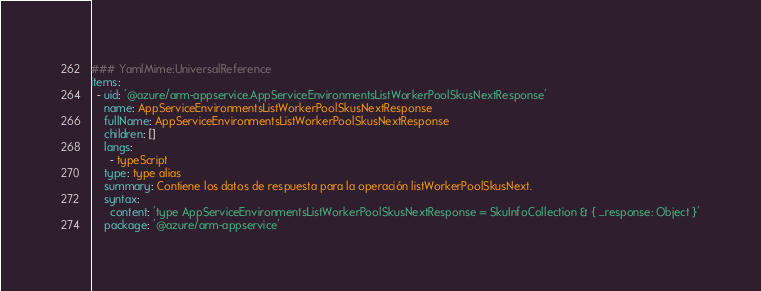<code> <loc_0><loc_0><loc_500><loc_500><_YAML_>### YamlMime:UniversalReference
items:
  - uid: '@azure/arm-appservice.AppServiceEnvironmentsListWorkerPoolSkusNextResponse'
    name: AppServiceEnvironmentsListWorkerPoolSkusNextResponse
    fullName: AppServiceEnvironmentsListWorkerPoolSkusNextResponse
    children: []
    langs:
      - typeScript
    type: type alias
    summary: Contiene los datos de respuesta para la operación listWorkerPoolSkusNext.
    syntax:
      content: 'type AppServiceEnvironmentsListWorkerPoolSkusNextResponse = SkuInfoCollection & { _response: Object }'
    package: '@azure/arm-appservice'</code> 